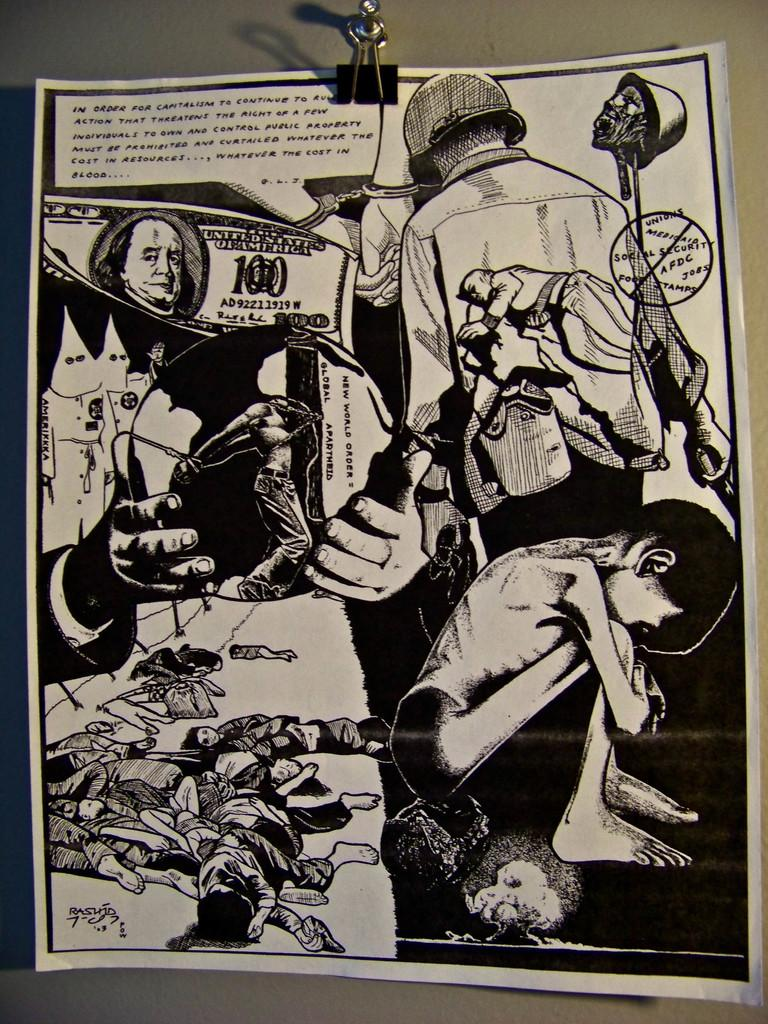<image>
Summarize the visual content of the image. A black and white illustrated page includes images of suffering and gore along with a 100 dollar Unites States bill. 